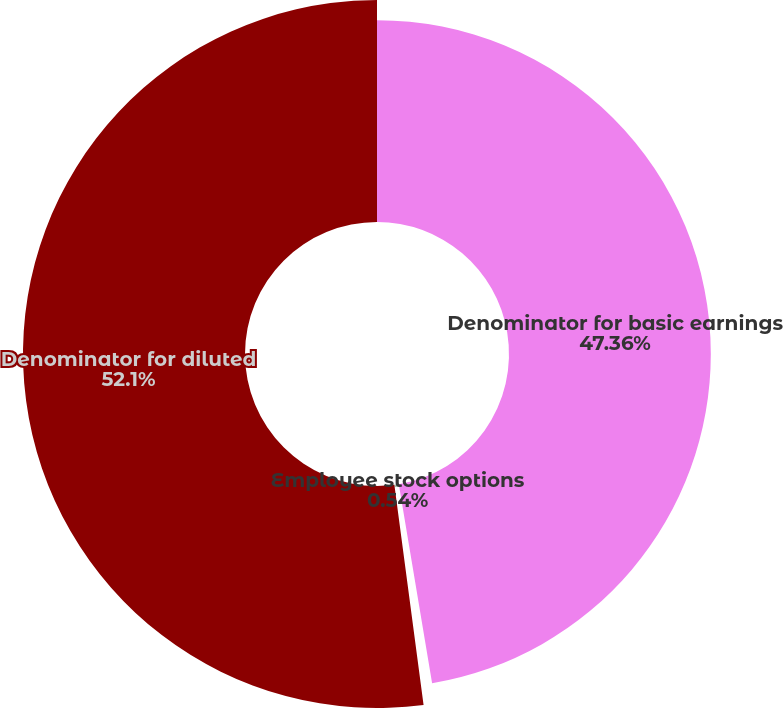<chart> <loc_0><loc_0><loc_500><loc_500><pie_chart><fcel>Denominator for basic earnings<fcel>Employee stock options<fcel>Denominator for diluted<nl><fcel>47.36%<fcel>0.54%<fcel>52.1%<nl></chart> 